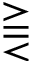Convert formula to latex. <formula><loc_0><loc_0><loc_500><loc_500>\gtreqqless</formula> 